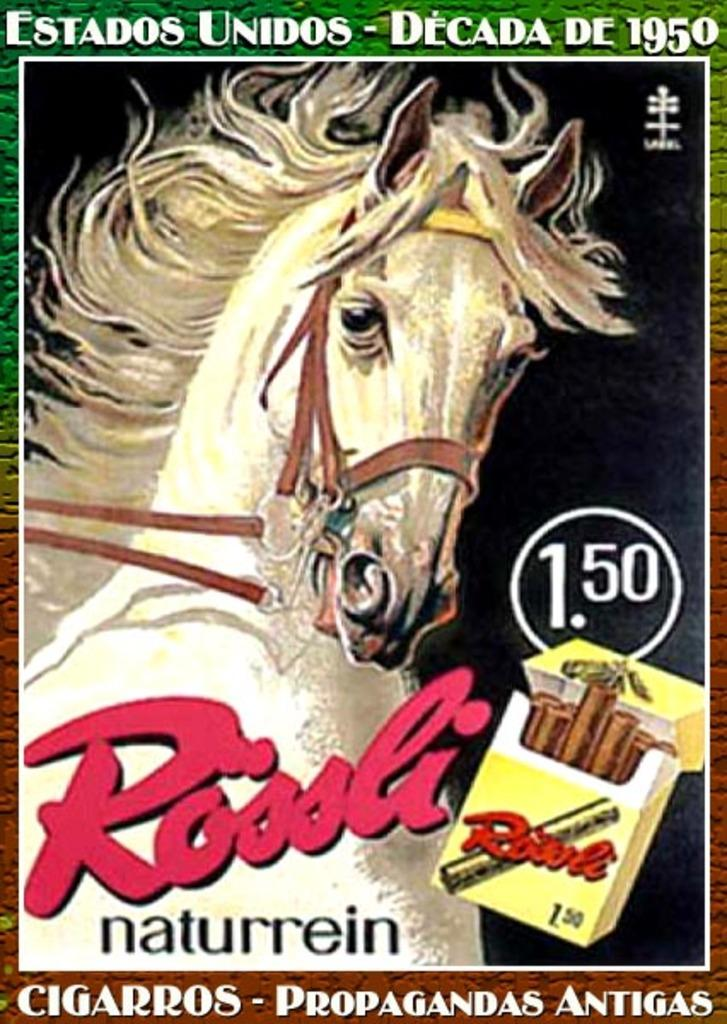What type of image is the subject of the conversation? The image is a poster. What is depicted on the poster? There is a horse depicted in a cigarette box on the poster. What else can be seen on the poster besides the horse? There is text written on the poster. How many dinosaurs are present in the image? There are no dinosaurs present in the image; it features a horse depicted in a cigarette box. What type of bomb is shown in the image? There is no bomb present in the image. 